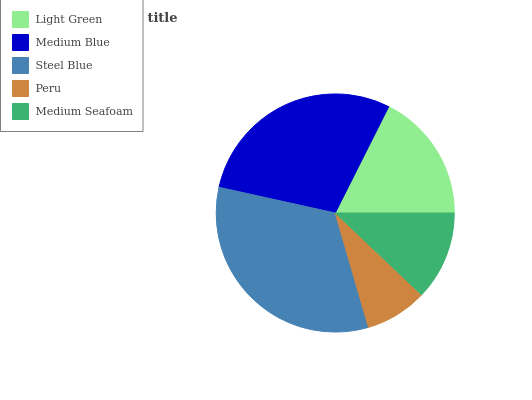Is Peru the minimum?
Answer yes or no. Yes. Is Steel Blue the maximum?
Answer yes or no. Yes. Is Medium Blue the minimum?
Answer yes or no. No. Is Medium Blue the maximum?
Answer yes or no. No. Is Medium Blue greater than Light Green?
Answer yes or no. Yes. Is Light Green less than Medium Blue?
Answer yes or no. Yes. Is Light Green greater than Medium Blue?
Answer yes or no. No. Is Medium Blue less than Light Green?
Answer yes or no. No. Is Light Green the high median?
Answer yes or no. Yes. Is Light Green the low median?
Answer yes or no. Yes. Is Medium Seafoam the high median?
Answer yes or no. No. Is Medium Seafoam the low median?
Answer yes or no. No. 